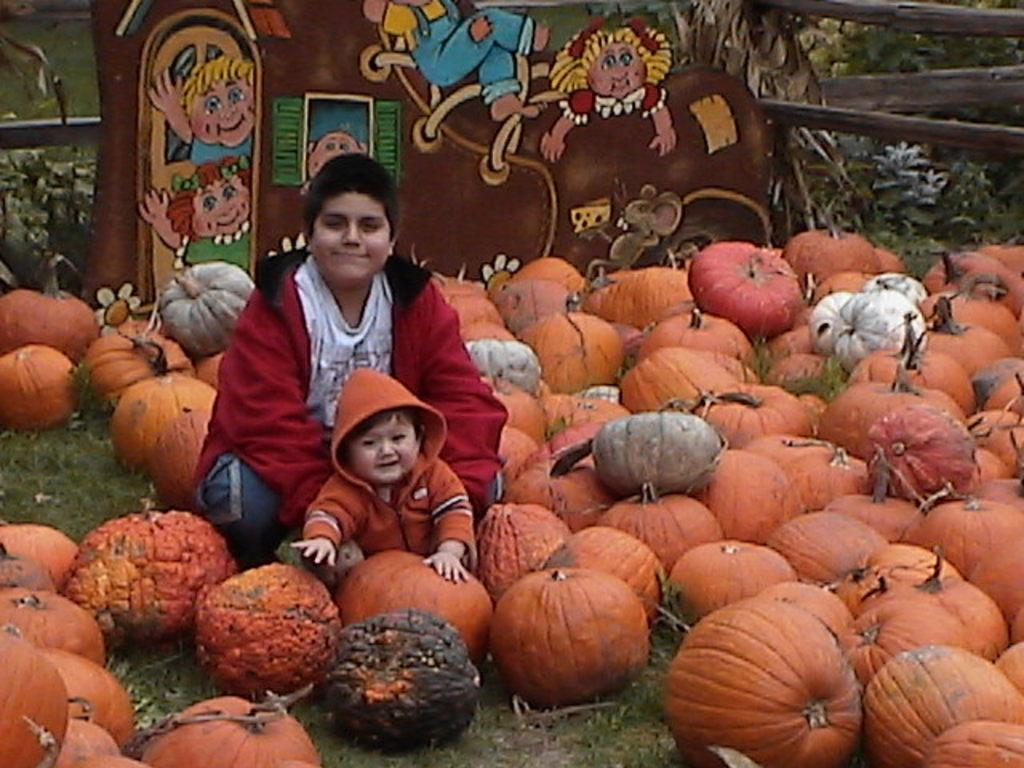What is the gender of the child in the image? The child in the image is a boy. What objects are present in the image along with the child? There are pumpkins, grass, stickers, and plants in the background of the image. Can you describe the setting of the image? The image features a boy surrounded by pumpkins, grass, and plants in the background. Where is the cave located in the image? There is no cave present in the image. What type of wheel is being used by the judge in the image? There is no judge or wheel present in the image. 